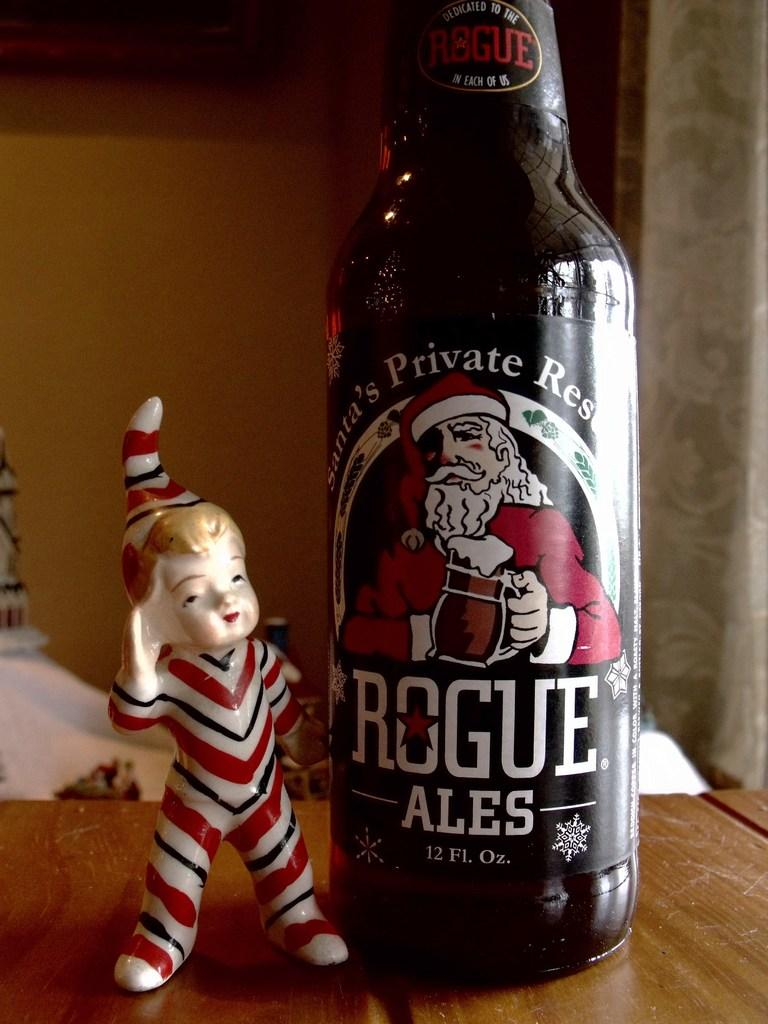<image>
Write a terse but informative summary of the picture. A bottle of beer that has a santa clause on it called Rogue Ales and has an elf statue next to it 